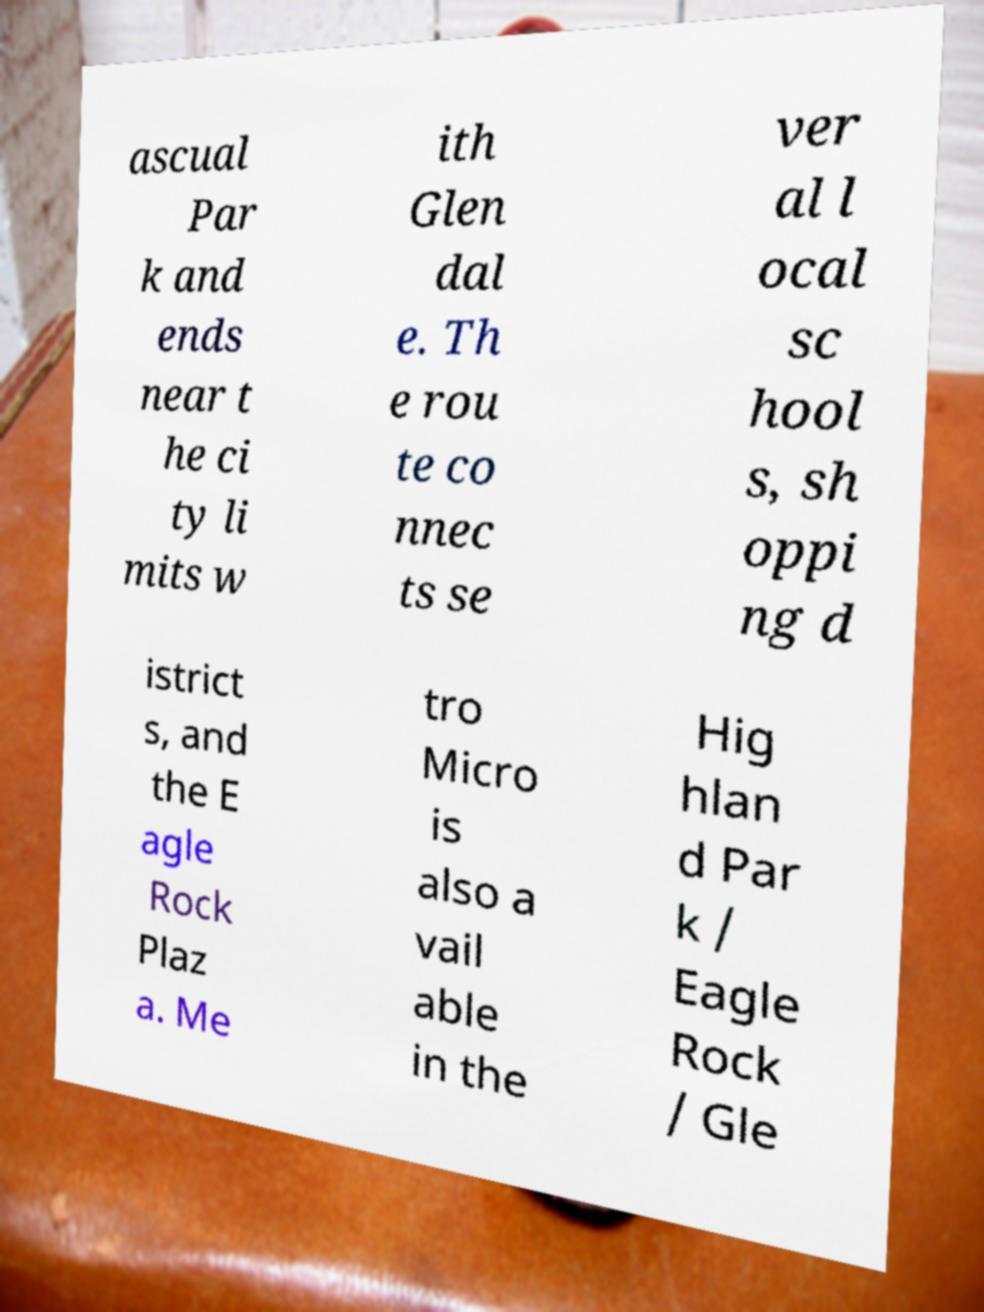Please read and relay the text visible in this image. What does it say? ascual Par k and ends near t he ci ty li mits w ith Glen dal e. Th e rou te co nnec ts se ver al l ocal sc hool s, sh oppi ng d istrict s, and the E agle Rock Plaz a. Me tro Micro is also a vail able in the Hig hlan d Par k / Eagle Rock / Gle 